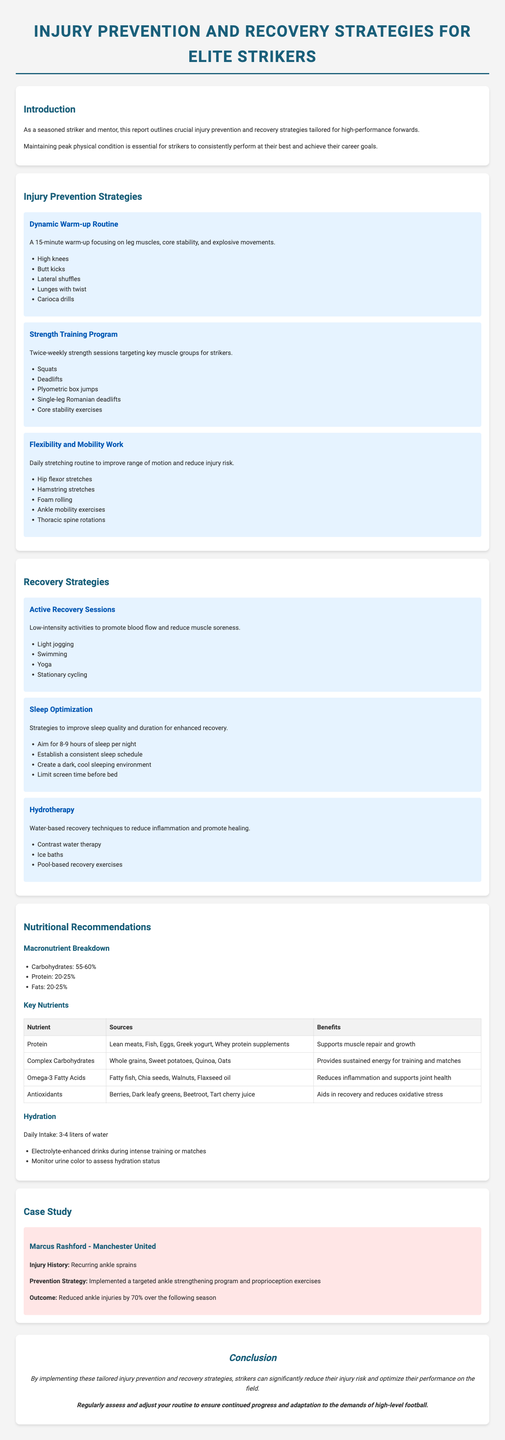What is the report title? The report title is mentioned at the beginning of the document, identifying the focus on injury prevention strategies for strikers.
Answer: Injury Prevention and Recovery Strategies for Elite Strikers How many injury prevention strategies are listed? The document provides a list of strategies aimed at preventing injuries, which can be counted in the respective section.
Answer: Three What is one exercise included in the Dynamic Warm-up Routine? The Dynamic Warm-up Routine consists of various exercises, one of which is highlighted for easy identification.
Answer: High knees What percentage of daily macronutrient intake is recommended for carbohydrates? The macronutrient breakdown section specifies the recommended range for carbohydrates as a percentage of total intake.
Answer: 55-60% What is the daily water intake recommendation? The hydration section provides a clear statement regarding the amount of water one should consume each day.
Answer: 3-4 liters of water Which player is featured in the case study? The case study section identifies a specific player to illustrate the effectiveness of the strategies discussed.
Answer: Marcus Rashford What benefit does protein provide according to the nutritional recommendations? The document outlines various nutrients and their benefits, particularly highlighting what protein supports.
Answer: Supports muscle repair and growth What is the outcome of Marcus Rashford's targeted prevention strategy? The case study concludes with the impact of the prevention strategy on the player's injury history, providing a quantifiable result.
Answer: Reduced ankle injuries by 70% over the following season What is a recommended activity for active recovery sessions? The recovery strategy section includes several low-intensity activities suitable for recovery, allowing for a few possible answers but targeting one.
Answer: Light jogging 